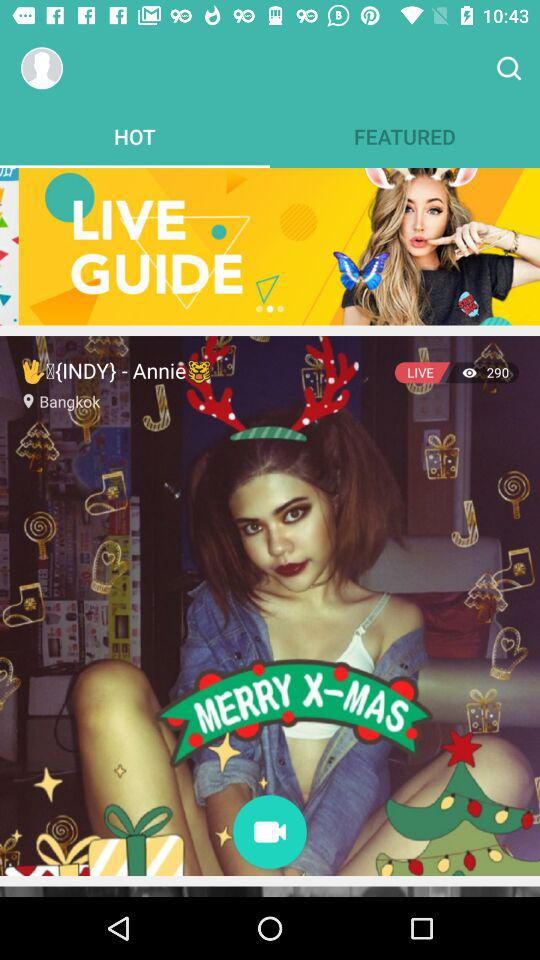What is the name of the user? The name of the user is Annie. 